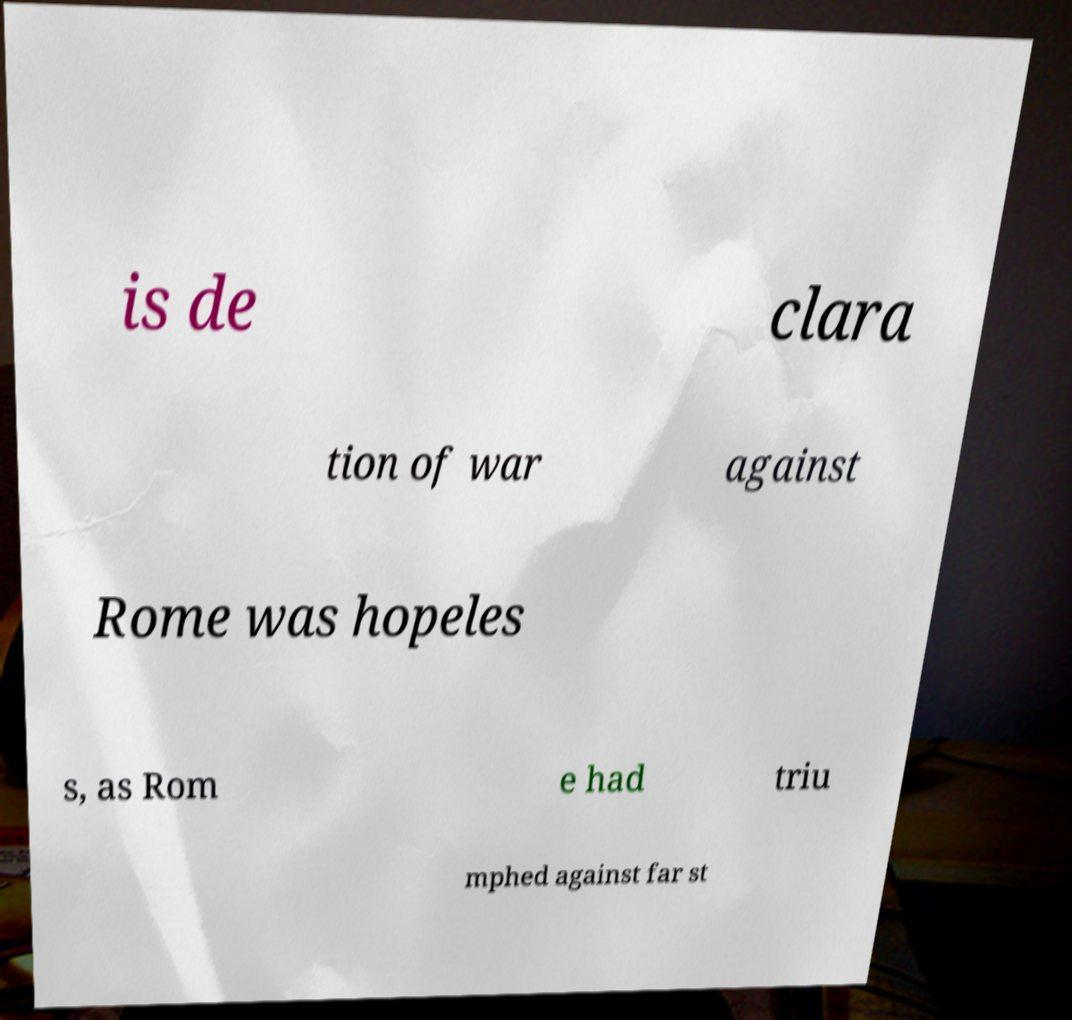There's text embedded in this image that I need extracted. Can you transcribe it verbatim? is de clara tion of war against Rome was hopeles s, as Rom e had triu mphed against far st 